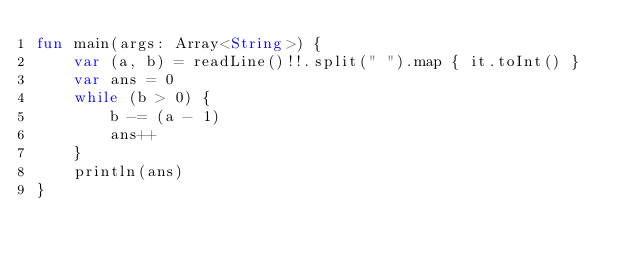Convert code to text. <code><loc_0><loc_0><loc_500><loc_500><_Kotlin_>fun main(args: Array<String>) {
    var (a, b) = readLine()!!.split(" ").map { it.toInt() }
    var ans = 0
    while (b > 0) {
        b -= (a - 1)
        ans++
    }
    println(ans)
}
</code> 